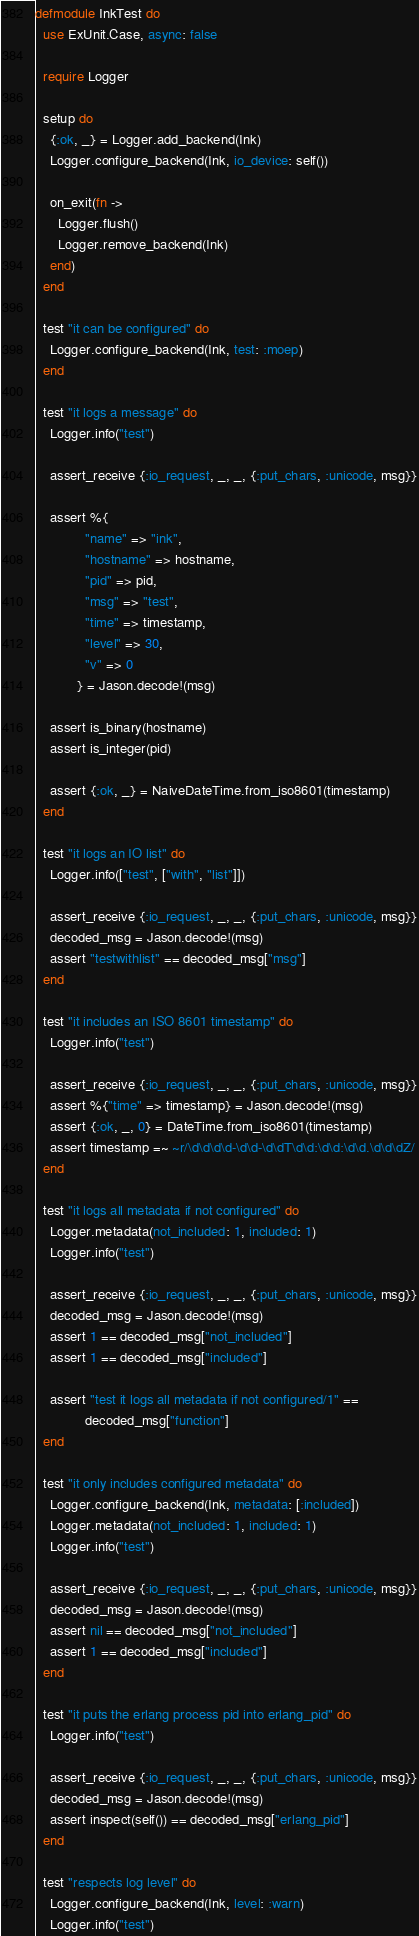Convert code to text. <code><loc_0><loc_0><loc_500><loc_500><_Elixir_>defmodule InkTest do
  use ExUnit.Case, async: false

  require Logger

  setup do
    {:ok, _} = Logger.add_backend(Ink)
    Logger.configure_backend(Ink, io_device: self())

    on_exit(fn ->
      Logger.flush()
      Logger.remove_backend(Ink)
    end)
  end

  test "it can be configured" do
    Logger.configure_backend(Ink, test: :moep)
  end

  test "it logs a message" do
    Logger.info("test")

    assert_receive {:io_request, _, _, {:put_chars, :unicode, msg}}

    assert %{
             "name" => "ink",
             "hostname" => hostname,
             "pid" => pid,
             "msg" => "test",
             "time" => timestamp,
             "level" => 30,
             "v" => 0
           } = Jason.decode!(msg)

    assert is_binary(hostname)
    assert is_integer(pid)

    assert {:ok, _} = NaiveDateTime.from_iso8601(timestamp)
  end

  test "it logs an IO list" do
    Logger.info(["test", ["with", "list"]])

    assert_receive {:io_request, _, _, {:put_chars, :unicode, msg}}
    decoded_msg = Jason.decode!(msg)
    assert "testwithlist" == decoded_msg["msg"]
  end

  test "it includes an ISO 8601 timestamp" do
    Logger.info("test")

    assert_receive {:io_request, _, _, {:put_chars, :unicode, msg}}
    assert %{"time" => timestamp} = Jason.decode!(msg)
    assert {:ok, _, 0} = DateTime.from_iso8601(timestamp)
    assert timestamp =~ ~r/\d\d\d\d-\d\d-\d\dT\d\d:\d\d:\d\d.\d\d\dZ/
  end

  test "it logs all metadata if not configured" do
    Logger.metadata(not_included: 1, included: 1)
    Logger.info("test")

    assert_receive {:io_request, _, _, {:put_chars, :unicode, msg}}
    decoded_msg = Jason.decode!(msg)
    assert 1 == decoded_msg["not_included"]
    assert 1 == decoded_msg["included"]

    assert "test it logs all metadata if not configured/1" ==
             decoded_msg["function"]
  end

  test "it only includes configured metadata" do
    Logger.configure_backend(Ink, metadata: [:included])
    Logger.metadata(not_included: 1, included: 1)
    Logger.info("test")

    assert_receive {:io_request, _, _, {:put_chars, :unicode, msg}}
    decoded_msg = Jason.decode!(msg)
    assert nil == decoded_msg["not_included"]
    assert 1 == decoded_msg["included"]
  end

  test "it puts the erlang process pid into erlang_pid" do
    Logger.info("test")

    assert_receive {:io_request, _, _, {:put_chars, :unicode, msg}}
    decoded_msg = Jason.decode!(msg)
    assert inspect(self()) == decoded_msg["erlang_pid"]
  end

  test "respects log level" do
    Logger.configure_backend(Ink, level: :warn)
    Logger.info("test")
</code> 